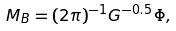Convert formula to latex. <formula><loc_0><loc_0><loc_500><loc_500>M _ { B } = ( 2 \pi ) ^ { - 1 } G ^ { - 0 . 5 } \Phi ,</formula> 